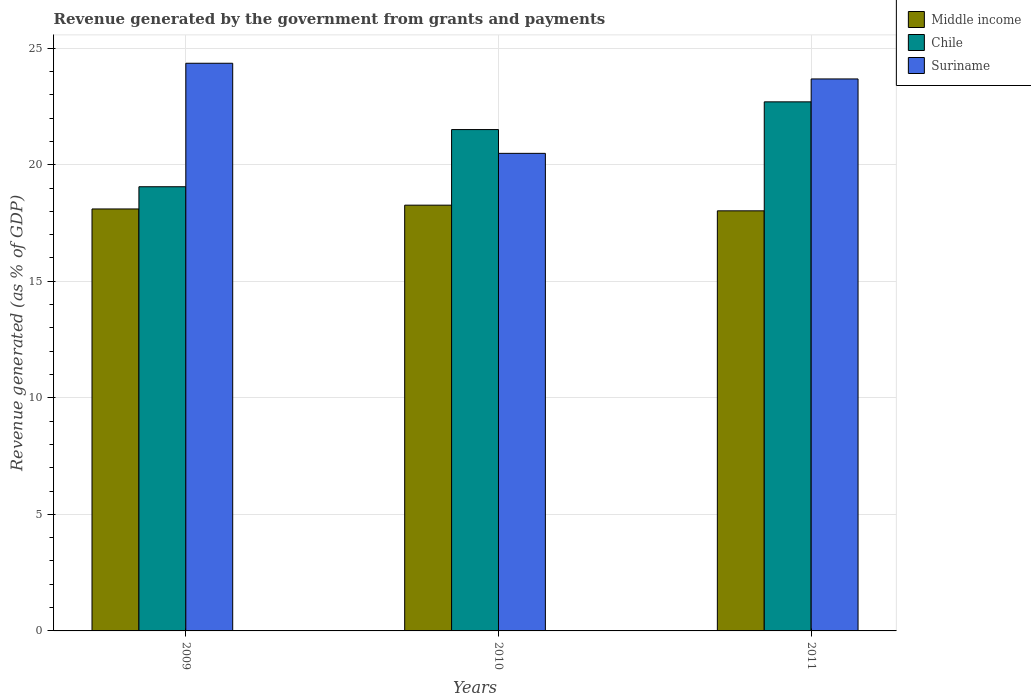How many groups of bars are there?
Ensure brevity in your answer.  3. Are the number of bars per tick equal to the number of legend labels?
Provide a short and direct response. Yes. In how many cases, is the number of bars for a given year not equal to the number of legend labels?
Your response must be concise. 0. What is the revenue generated by the government in Chile in 2011?
Ensure brevity in your answer.  22.7. Across all years, what is the maximum revenue generated by the government in Suriname?
Give a very brief answer. 24.35. Across all years, what is the minimum revenue generated by the government in Suriname?
Keep it short and to the point. 20.49. In which year was the revenue generated by the government in Middle income maximum?
Ensure brevity in your answer.  2010. In which year was the revenue generated by the government in Chile minimum?
Your answer should be very brief. 2009. What is the total revenue generated by the government in Suriname in the graph?
Keep it short and to the point. 68.52. What is the difference between the revenue generated by the government in Middle income in 2010 and that in 2011?
Offer a terse response. 0.24. What is the difference between the revenue generated by the government in Suriname in 2011 and the revenue generated by the government in Chile in 2009?
Provide a short and direct response. 4.62. What is the average revenue generated by the government in Middle income per year?
Your response must be concise. 18.13. In the year 2011, what is the difference between the revenue generated by the government in Middle income and revenue generated by the government in Chile?
Keep it short and to the point. -4.68. In how many years, is the revenue generated by the government in Suriname greater than 4 %?
Give a very brief answer. 3. What is the ratio of the revenue generated by the government in Chile in 2009 to that in 2010?
Your response must be concise. 0.89. Is the revenue generated by the government in Middle income in 2010 less than that in 2011?
Offer a terse response. No. Is the difference between the revenue generated by the government in Middle income in 2010 and 2011 greater than the difference between the revenue generated by the government in Chile in 2010 and 2011?
Offer a very short reply. Yes. What is the difference between the highest and the second highest revenue generated by the government in Middle income?
Ensure brevity in your answer.  0.16. What is the difference between the highest and the lowest revenue generated by the government in Suriname?
Provide a short and direct response. 3.87. In how many years, is the revenue generated by the government in Suriname greater than the average revenue generated by the government in Suriname taken over all years?
Your response must be concise. 2. Is the sum of the revenue generated by the government in Suriname in 2009 and 2011 greater than the maximum revenue generated by the government in Middle income across all years?
Provide a succinct answer. Yes. What does the 3rd bar from the left in 2011 represents?
Provide a succinct answer. Suriname. What does the 2nd bar from the right in 2009 represents?
Provide a succinct answer. Chile. Is it the case that in every year, the sum of the revenue generated by the government in Suriname and revenue generated by the government in Middle income is greater than the revenue generated by the government in Chile?
Your answer should be very brief. Yes. Does the graph contain any zero values?
Offer a very short reply. No. Where does the legend appear in the graph?
Your answer should be very brief. Top right. How many legend labels are there?
Your response must be concise. 3. What is the title of the graph?
Offer a very short reply. Revenue generated by the government from grants and payments. Does "Aruba" appear as one of the legend labels in the graph?
Offer a terse response. No. What is the label or title of the X-axis?
Make the answer very short. Years. What is the label or title of the Y-axis?
Your answer should be very brief. Revenue generated (as % of GDP). What is the Revenue generated (as % of GDP) in Middle income in 2009?
Your answer should be very brief. 18.1. What is the Revenue generated (as % of GDP) in Chile in 2009?
Make the answer very short. 19.05. What is the Revenue generated (as % of GDP) in Suriname in 2009?
Keep it short and to the point. 24.35. What is the Revenue generated (as % of GDP) in Middle income in 2010?
Your answer should be very brief. 18.26. What is the Revenue generated (as % of GDP) in Chile in 2010?
Keep it short and to the point. 21.51. What is the Revenue generated (as % of GDP) of Suriname in 2010?
Offer a very short reply. 20.49. What is the Revenue generated (as % of GDP) of Middle income in 2011?
Your answer should be compact. 18.02. What is the Revenue generated (as % of GDP) of Chile in 2011?
Keep it short and to the point. 22.7. What is the Revenue generated (as % of GDP) in Suriname in 2011?
Your response must be concise. 23.68. Across all years, what is the maximum Revenue generated (as % of GDP) in Middle income?
Provide a short and direct response. 18.26. Across all years, what is the maximum Revenue generated (as % of GDP) in Chile?
Offer a terse response. 22.7. Across all years, what is the maximum Revenue generated (as % of GDP) in Suriname?
Your answer should be very brief. 24.35. Across all years, what is the minimum Revenue generated (as % of GDP) of Middle income?
Ensure brevity in your answer.  18.02. Across all years, what is the minimum Revenue generated (as % of GDP) of Chile?
Ensure brevity in your answer.  19.05. Across all years, what is the minimum Revenue generated (as % of GDP) in Suriname?
Make the answer very short. 20.49. What is the total Revenue generated (as % of GDP) in Middle income in the graph?
Offer a terse response. 54.39. What is the total Revenue generated (as % of GDP) of Chile in the graph?
Ensure brevity in your answer.  63.26. What is the total Revenue generated (as % of GDP) in Suriname in the graph?
Provide a succinct answer. 68.52. What is the difference between the Revenue generated (as % of GDP) of Middle income in 2009 and that in 2010?
Offer a very short reply. -0.16. What is the difference between the Revenue generated (as % of GDP) of Chile in 2009 and that in 2010?
Give a very brief answer. -2.45. What is the difference between the Revenue generated (as % of GDP) in Suriname in 2009 and that in 2010?
Provide a succinct answer. 3.87. What is the difference between the Revenue generated (as % of GDP) in Middle income in 2009 and that in 2011?
Ensure brevity in your answer.  0.08. What is the difference between the Revenue generated (as % of GDP) of Chile in 2009 and that in 2011?
Ensure brevity in your answer.  -3.64. What is the difference between the Revenue generated (as % of GDP) in Suriname in 2009 and that in 2011?
Provide a succinct answer. 0.67. What is the difference between the Revenue generated (as % of GDP) of Middle income in 2010 and that in 2011?
Provide a short and direct response. 0.24. What is the difference between the Revenue generated (as % of GDP) of Chile in 2010 and that in 2011?
Keep it short and to the point. -1.19. What is the difference between the Revenue generated (as % of GDP) of Suriname in 2010 and that in 2011?
Offer a terse response. -3.19. What is the difference between the Revenue generated (as % of GDP) of Middle income in 2009 and the Revenue generated (as % of GDP) of Chile in 2010?
Your answer should be compact. -3.41. What is the difference between the Revenue generated (as % of GDP) of Middle income in 2009 and the Revenue generated (as % of GDP) of Suriname in 2010?
Your response must be concise. -2.39. What is the difference between the Revenue generated (as % of GDP) of Chile in 2009 and the Revenue generated (as % of GDP) of Suriname in 2010?
Provide a short and direct response. -1.43. What is the difference between the Revenue generated (as % of GDP) in Middle income in 2009 and the Revenue generated (as % of GDP) in Chile in 2011?
Ensure brevity in your answer.  -4.59. What is the difference between the Revenue generated (as % of GDP) of Middle income in 2009 and the Revenue generated (as % of GDP) of Suriname in 2011?
Your answer should be compact. -5.58. What is the difference between the Revenue generated (as % of GDP) in Chile in 2009 and the Revenue generated (as % of GDP) in Suriname in 2011?
Your response must be concise. -4.62. What is the difference between the Revenue generated (as % of GDP) in Middle income in 2010 and the Revenue generated (as % of GDP) in Chile in 2011?
Give a very brief answer. -4.43. What is the difference between the Revenue generated (as % of GDP) in Middle income in 2010 and the Revenue generated (as % of GDP) in Suriname in 2011?
Make the answer very short. -5.41. What is the difference between the Revenue generated (as % of GDP) in Chile in 2010 and the Revenue generated (as % of GDP) in Suriname in 2011?
Your answer should be very brief. -2.17. What is the average Revenue generated (as % of GDP) of Middle income per year?
Make the answer very short. 18.13. What is the average Revenue generated (as % of GDP) of Chile per year?
Provide a short and direct response. 21.09. What is the average Revenue generated (as % of GDP) in Suriname per year?
Make the answer very short. 22.84. In the year 2009, what is the difference between the Revenue generated (as % of GDP) of Middle income and Revenue generated (as % of GDP) of Chile?
Provide a succinct answer. -0.95. In the year 2009, what is the difference between the Revenue generated (as % of GDP) of Middle income and Revenue generated (as % of GDP) of Suriname?
Provide a succinct answer. -6.25. In the year 2009, what is the difference between the Revenue generated (as % of GDP) in Chile and Revenue generated (as % of GDP) in Suriname?
Ensure brevity in your answer.  -5.3. In the year 2010, what is the difference between the Revenue generated (as % of GDP) in Middle income and Revenue generated (as % of GDP) in Chile?
Offer a terse response. -3.24. In the year 2010, what is the difference between the Revenue generated (as % of GDP) of Middle income and Revenue generated (as % of GDP) of Suriname?
Your answer should be compact. -2.22. In the year 2010, what is the difference between the Revenue generated (as % of GDP) of Chile and Revenue generated (as % of GDP) of Suriname?
Make the answer very short. 1.02. In the year 2011, what is the difference between the Revenue generated (as % of GDP) of Middle income and Revenue generated (as % of GDP) of Chile?
Keep it short and to the point. -4.68. In the year 2011, what is the difference between the Revenue generated (as % of GDP) in Middle income and Revenue generated (as % of GDP) in Suriname?
Keep it short and to the point. -5.66. In the year 2011, what is the difference between the Revenue generated (as % of GDP) in Chile and Revenue generated (as % of GDP) in Suriname?
Ensure brevity in your answer.  -0.98. What is the ratio of the Revenue generated (as % of GDP) in Middle income in 2009 to that in 2010?
Your answer should be very brief. 0.99. What is the ratio of the Revenue generated (as % of GDP) of Chile in 2009 to that in 2010?
Your response must be concise. 0.89. What is the ratio of the Revenue generated (as % of GDP) of Suriname in 2009 to that in 2010?
Make the answer very short. 1.19. What is the ratio of the Revenue generated (as % of GDP) of Middle income in 2009 to that in 2011?
Offer a terse response. 1. What is the ratio of the Revenue generated (as % of GDP) in Chile in 2009 to that in 2011?
Give a very brief answer. 0.84. What is the ratio of the Revenue generated (as % of GDP) in Suriname in 2009 to that in 2011?
Keep it short and to the point. 1.03. What is the ratio of the Revenue generated (as % of GDP) in Middle income in 2010 to that in 2011?
Your answer should be compact. 1.01. What is the ratio of the Revenue generated (as % of GDP) in Chile in 2010 to that in 2011?
Make the answer very short. 0.95. What is the ratio of the Revenue generated (as % of GDP) in Suriname in 2010 to that in 2011?
Your response must be concise. 0.87. What is the difference between the highest and the second highest Revenue generated (as % of GDP) of Middle income?
Your answer should be compact. 0.16. What is the difference between the highest and the second highest Revenue generated (as % of GDP) in Chile?
Offer a very short reply. 1.19. What is the difference between the highest and the second highest Revenue generated (as % of GDP) of Suriname?
Make the answer very short. 0.67. What is the difference between the highest and the lowest Revenue generated (as % of GDP) in Middle income?
Your answer should be very brief. 0.24. What is the difference between the highest and the lowest Revenue generated (as % of GDP) of Chile?
Your answer should be very brief. 3.64. What is the difference between the highest and the lowest Revenue generated (as % of GDP) in Suriname?
Provide a succinct answer. 3.87. 